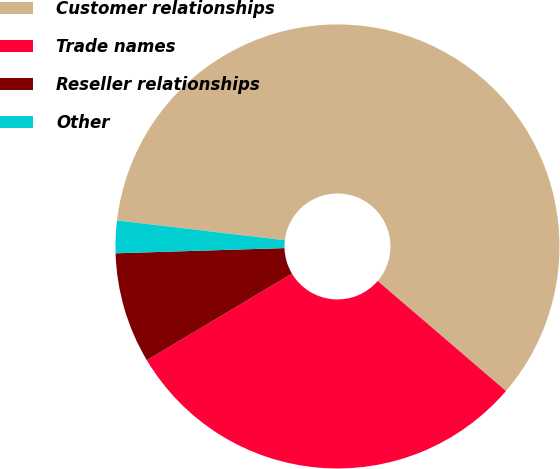Convert chart. <chart><loc_0><loc_0><loc_500><loc_500><pie_chart><fcel>Customer relationships<fcel>Trade names<fcel>Reseller relationships<fcel>Other<nl><fcel>59.41%<fcel>30.15%<fcel>8.07%<fcel>2.36%<nl></chart> 